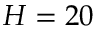Convert formula to latex. <formula><loc_0><loc_0><loc_500><loc_500>H = 2 0</formula> 